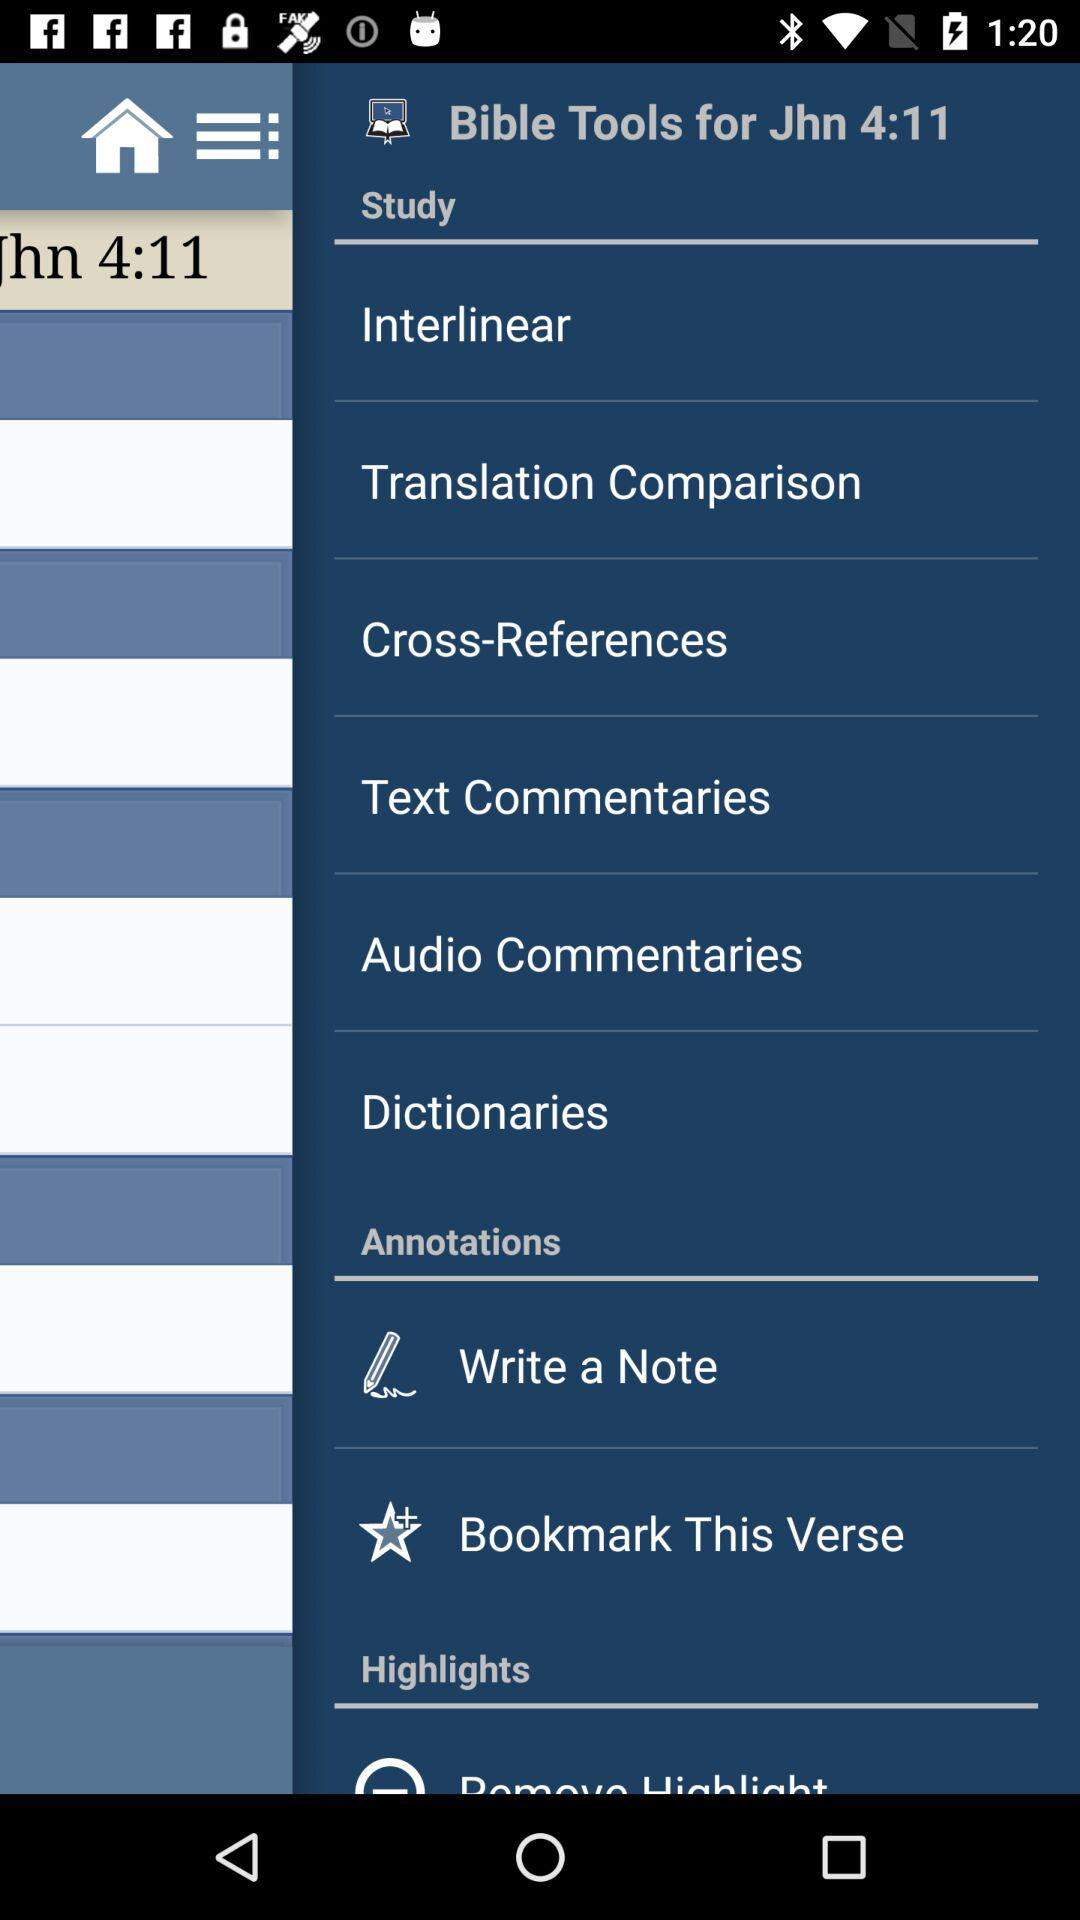What is the app name? The app name is "Blue Letter Bible". 